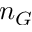Convert formula to latex. <formula><loc_0><loc_0><loc_500><loc_500>n _ { G }</formula> 